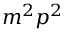<formula> <loc_0><loc_0><loc_500><loc_500>m ^ { 2 } p ^ { 2 }</formula> 